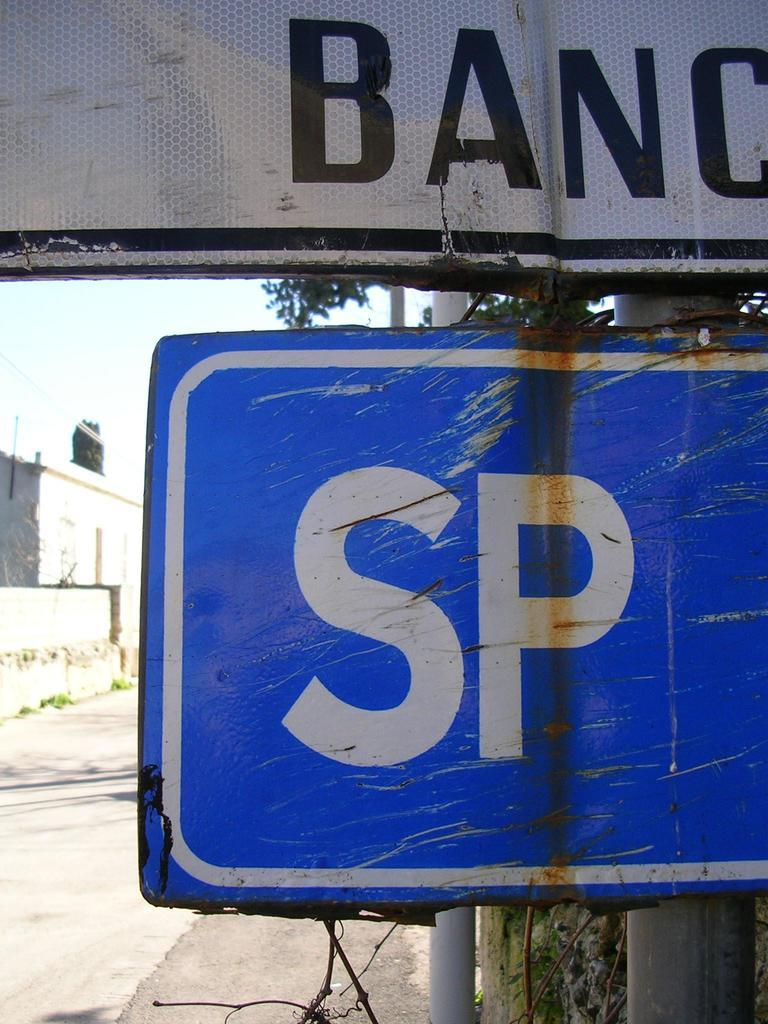<image>
Provide a brief description of the given image. A white Blanc sign is above a SP sign. 